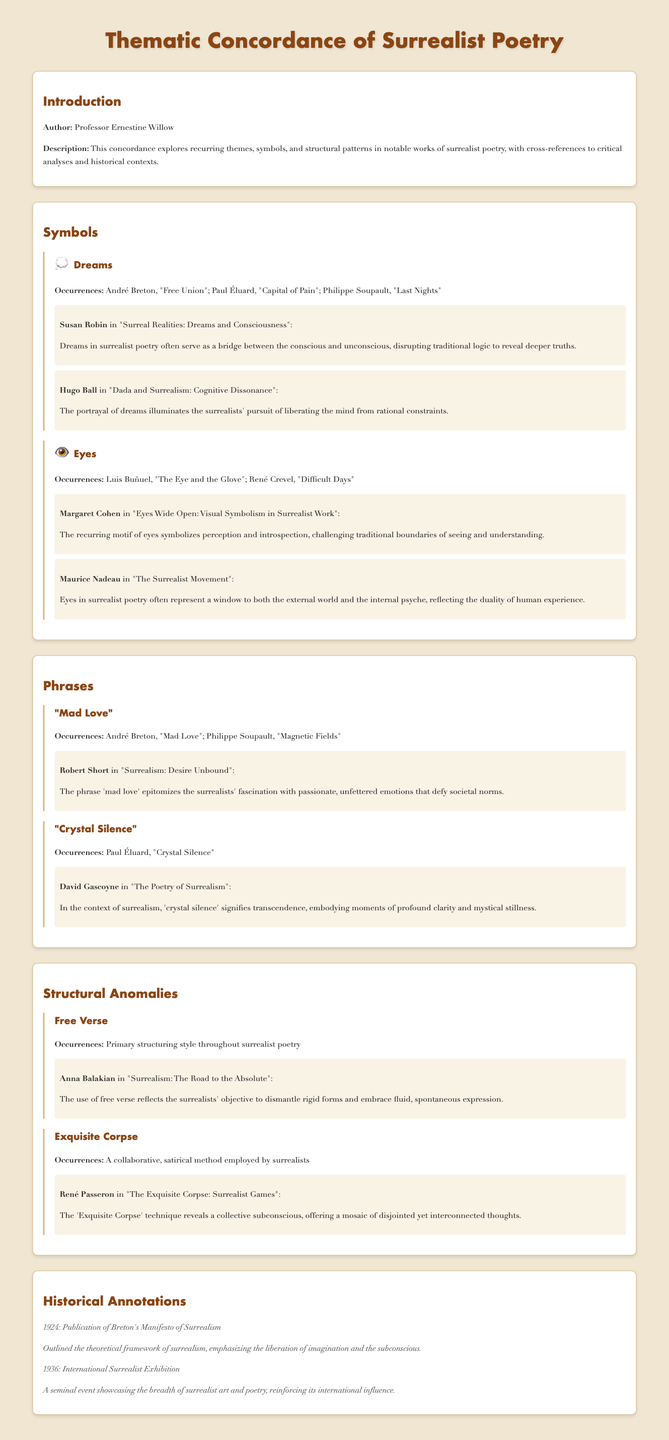What is the title of the document? The title of the document is provided in the header section, describing the thematic focus of surrealist poetry.
Answer: Thematic Concordance of Surrealist Poetry Who is the author of the document? The author's name is mentioned in the introduction section of the document.
Answer: Professor Ernestine Willow What recurring symbol is associated with "The Eye and the Glove"? This specific work mentions a prominent symbol in surrealism, noted in the section on symbols.
Answer: Eyes What year was the Manifesto of Surrealism published? The historical annotation section lists significant events in surrealism, including this publication year.
Answer: 1924 Which surrealist poet is linked with "Mad Love"? The occurrences of this phrase are highlighted in the phrases section, identifying its association.
Answer: André Breton What technique reveals a collective subconscious? This is described in the structural anomalies section related to collaborative surrealist methods.
Answer: Exquisite Corpse How does Susan Robin interpret dreams in surrealist poetry? The interpretation by Susan Robin is found in the symbols section, discussing the role of dreams.
Answer: A bridge between the conscious and unconscious What is the primary structuring style throughout surrealist poetry? This is mentioned in the structural anomalies section regarding poetic forms.
Answer: Free Verse Who wrote "Surreal Realities: Dreams and Consciousness"? The interpretation attributed to a specific scholar is provided in the document under the dreams symbol section.
Answer: Susan Robin 